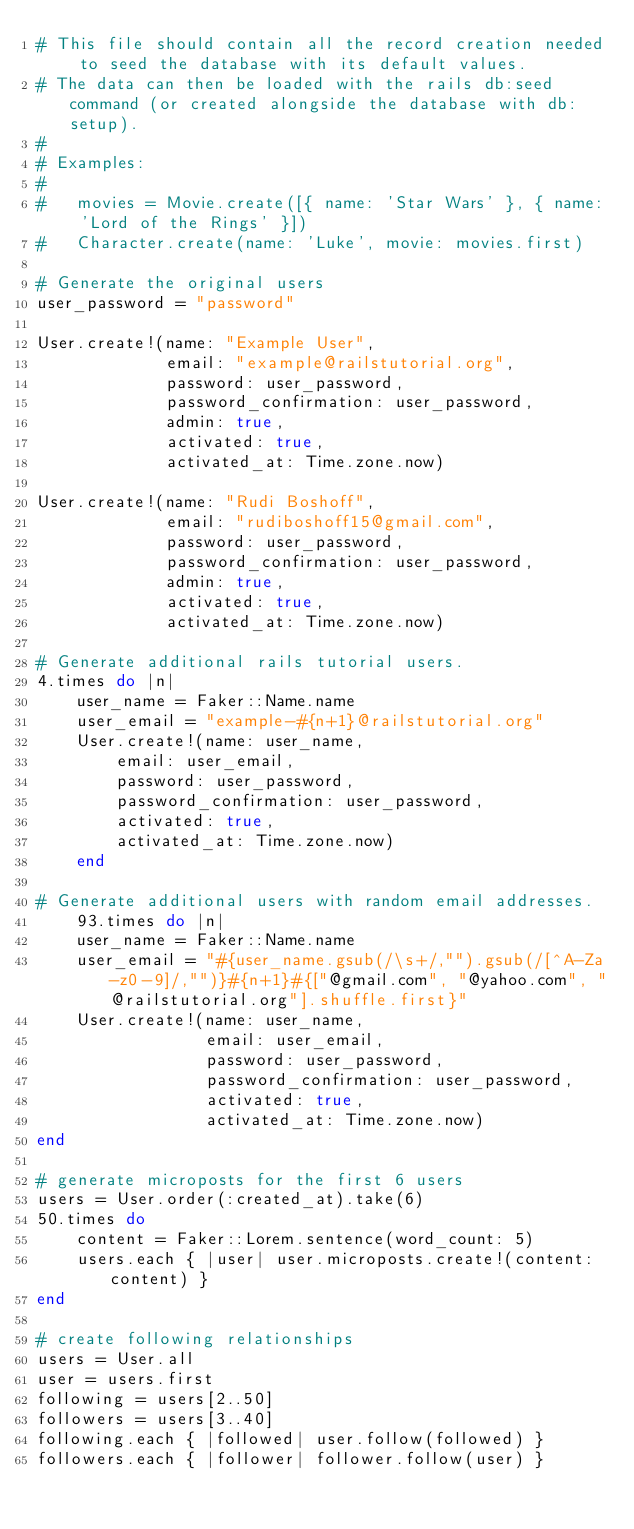Convert code to text. <code><loc_0><loc_0><loc_500><loc_500><_Ruby_># This file should contain all the record creation needed to seed the database with its default values.
# The data can then be loaded with the rails db:seed command (or created alongside the database with db:setup).
#
# Examples:
#
#   movies = Movie.create([{ name: 'Star Wars' }, { name: 'Lord of the Rings' }])
#   Character.create(name: 'Luke', movie: movies.first)

# Generate the original users
user_password = "password"

User.create!(name: "Example User",
             email: "example@railstutorial.org",
             password: user_password,
             password_confirmation: user_password,
             admin: true,
             activated: true,
             activated_at: Time.zone.now)

User.create!(name: "Rudi Boshoff",
             email: "rudiboshoff15@gmail.com",
             password: user_password,
             password_confirmation: user_password,
             admin: true,
             activated: true,
             activated_at: Time.zone.now)

# Generate additional rails tutorial users.
4.times do |n|
    user_name = Faker::Name.name
    user_email = "example-#{n+1}@railstutorial.org"
    User.create!(name: user_name,
        email: user_email,
        password: user_password,
        password_confirmation: user_password,
        activated: true,
        activated_at: Time.zone.now)
    end
    
# Generate additional users with random email addresses.
    93.times do |n|
    user_name = Faker::Name.name
    user_email = "#{user_name.gsub(/\s+/,"").gsub(/[^A-Za-z0-9]/,"")}#{n+1}#{["@gmail.com", "@yahoo.com", "@railstutorial.org"].shuffle.first}"
    User.create!(name: user_name,
                 email: user_email,
                 password: user_password,
                 password_confirmation: user_password,
                 activated: true,
                 activated_at: Time.zone.now)
end

# generate microposts for the first 6 users
users = User.order(:created_at).take(6)
50.times do
    content = Faker::Lorem.sentence(word_count: 5)
    users.each { |user| user.microposts.create!(content: content) }
end

# create following relationships
users = User.all
user = users.first
following = users[2..50]
followers = users[3..40]
following.each { |followed| user.follow(followed) }
followers.each { |follower| follower.follow(user) }</code> 